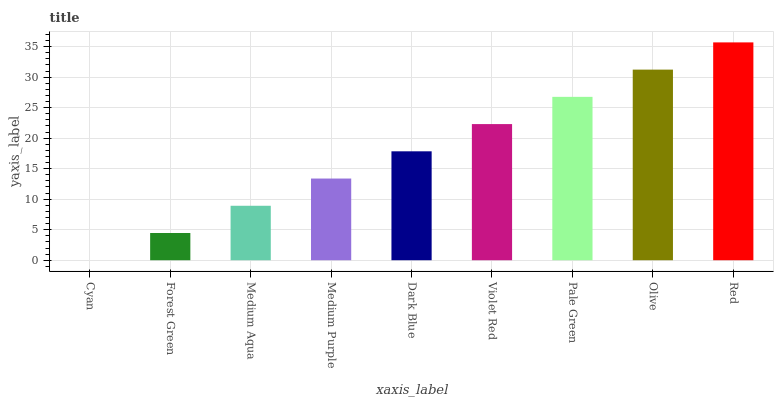Is Cyan the minimum?
Answer yes or no. Yes. Is Red the maximum?
Answer yes or no. Yes. Is Forest Green the minimum?
Answer yes or no. No. Is Forest Green the maximum?
Answer yes or no. No. Is Forest Green greater than Cyan?
Answer yes or no. Yes. Is Cyan less than Forest Green?
Answer yes or no. Yes. Is Cyan greater than Forest Green?
Answer yes or no. No. Is Forest Green less than Cyan?
Answer yes or no. No. Is Dark Blue the high median?
Answer yes or no. Yes. Is Dark Blue the low median?
Answer yes or no. Yes. Is Cyan the high median?
Answer yes or no. No. Is Olive the low median?
Answer yes or no. No. 